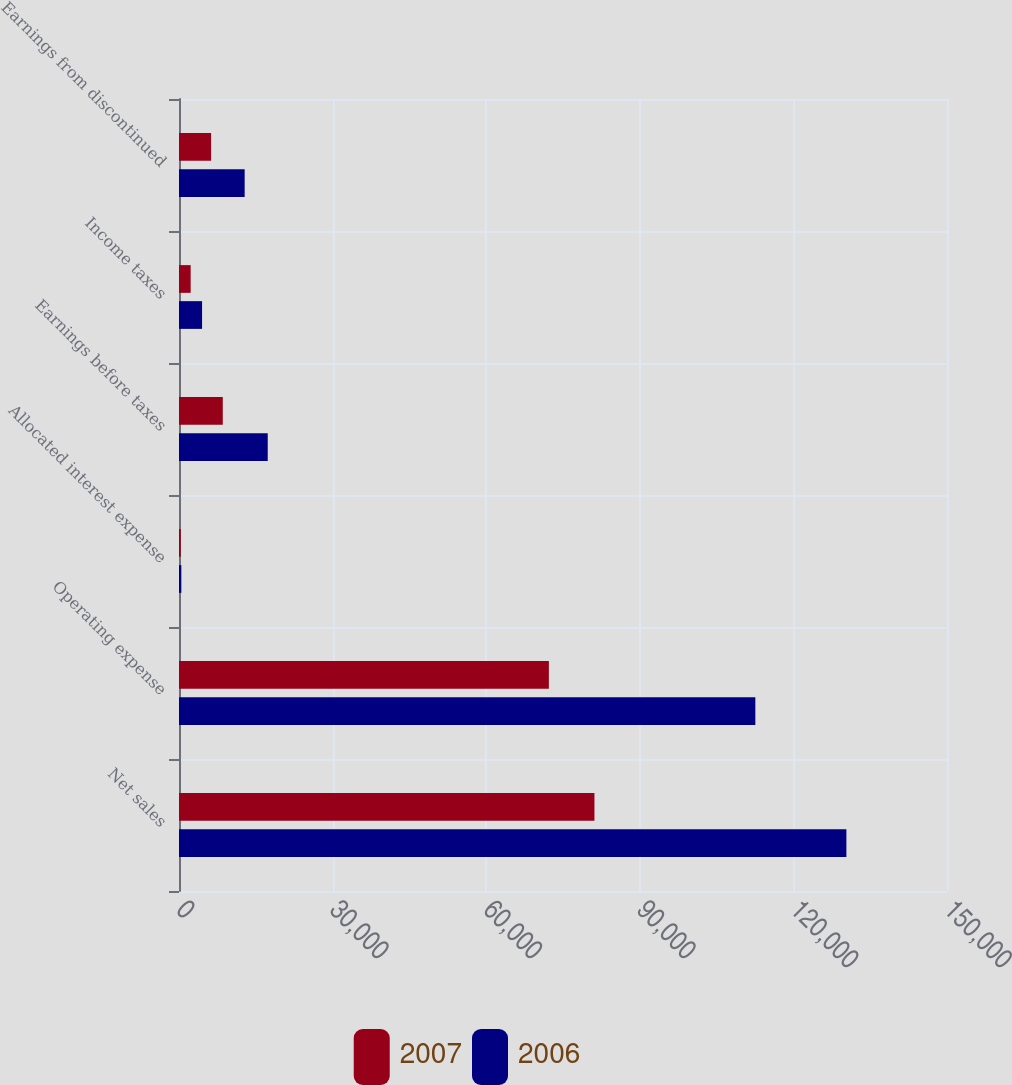<chart> <loc_0><loc_0><loc_500><loc_500><stacked_bar_chart><ecel><fcel>Net sales<fcel>Operating expense<fcel>Allocated interest expense<fcel>Earnings before taxes<fcel>Income taxes<fcel>Earnings from discontinued<nl><fcel>2007<fcel>81141<fcel>72239<fcel>351<fcel>8551<fcel>2279<fcel>6272<nl><fcel>2006<fcel>130348<fcel>112565<fcel>454<fcel>17329<fcel>4506<fcel>12823<nl></chart> 